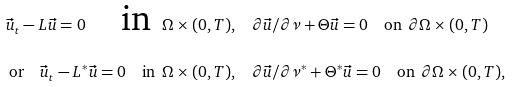Convert formula to latex. <formula><loc_0><loc_0><loc_500><loc_500>\vec { u } _ { t } - L \vec { u } = 0 \quad \text {in } \, \Omega \times ( 0 , T ) , & \quad \partial \vec { u } / \partial \nu + \Theta \vec { u } = 0 \quad \text {on } \, \partial \Omega \times ( 0 , T ) \\ \text {or} \quad \vec { u } _ { t } - L ^ { * } \vec { u } = 0 \quad \text {in } \, \Omega \times ( 0 , T ) , & \quad \partial \vec { u } / \partial \nu ^ { * } + \Theta ^ { * } \vec { u } = 0 \quad \text {on } \, \partial \Omega \times ( 0 , T ) ,</formula> 